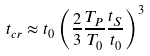<formula> <loc_0><loc_0><loc_500><loc_500>t _ { c r } \approx t _ { 0 } \left ( \frac { 2 } { 3 } \frac { T _ { P } } { T _ { 0 } } \frac { t _ { S } } { t _ { 0 } } \right ) ^ { 3 }</formula> 